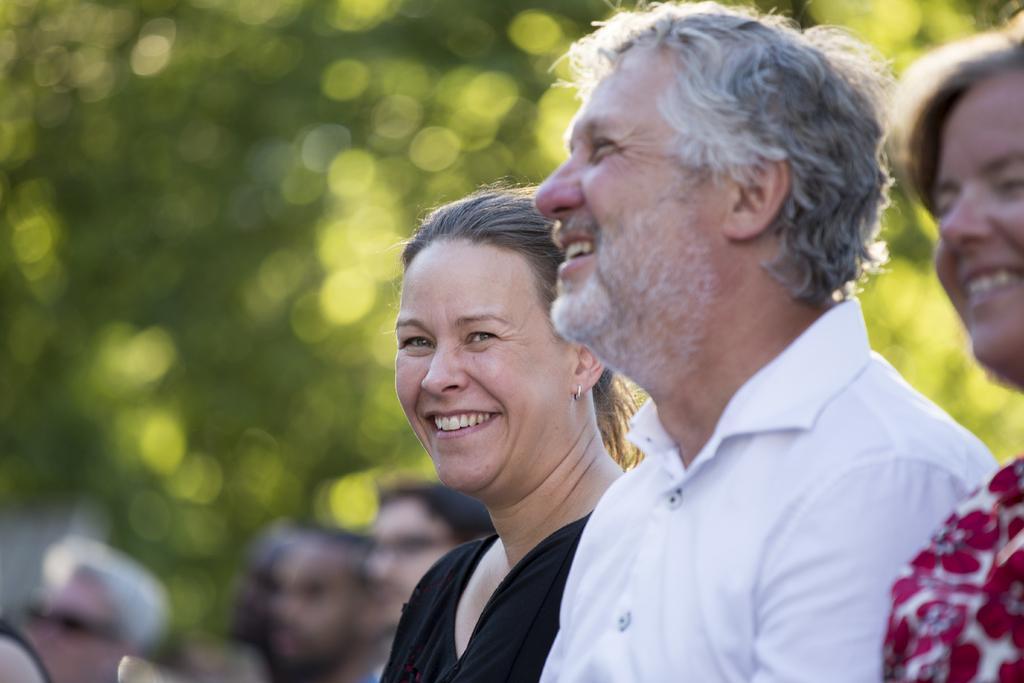Describe this image in one or two sentences. There are three people smiling. In the background it is blurry and it is green and we can see people. 